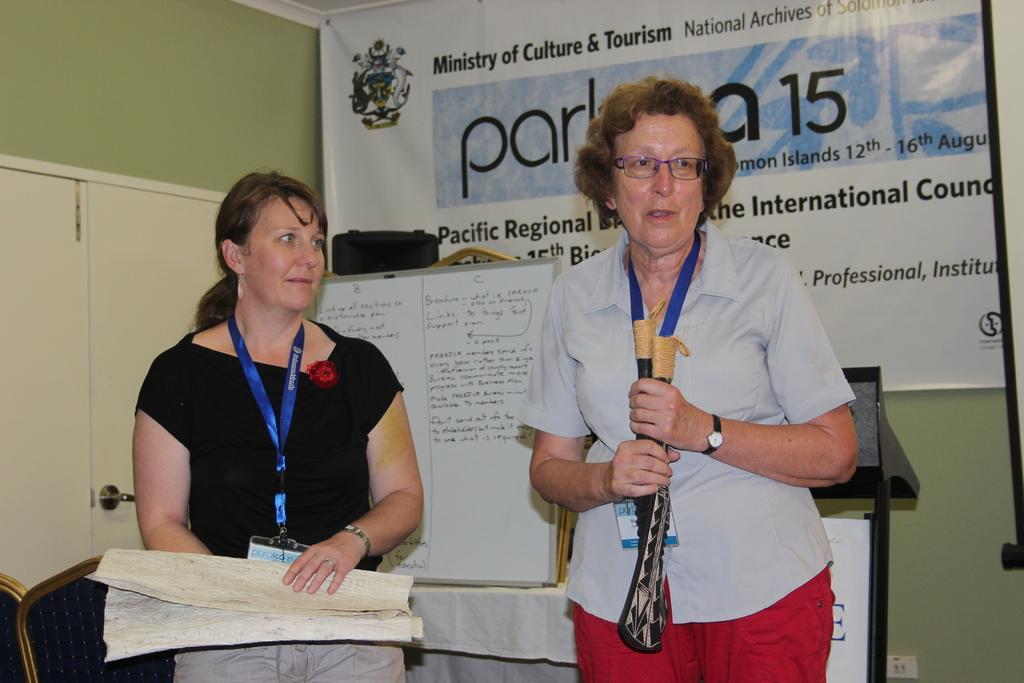In one or two sentences, can you explain what this image depicts? In the front of the image I can see two women are standing and holding objects. In the background of the image there is a hoarding, cupboard, whiteboard, podium, table, chairs, walls and objects. Something is written on the hoarding and white board. 